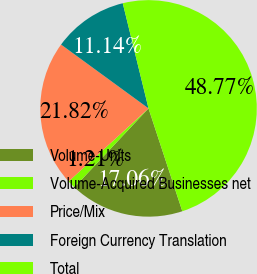Convert chart. <chart><loc_0><loc_0><loc_500><loc_500><pie_chart><fcel>Volume-Units<fcel>Volume-Acquired Businesses net<fcel>Price/Mix<fcel>Foreign Currency Translation<fcel>Total<nl><fcel>17.06%<fcel>1.21%<fcel>21.82%<fcel>11.14%<fcel>48.77%<nl></chart> 